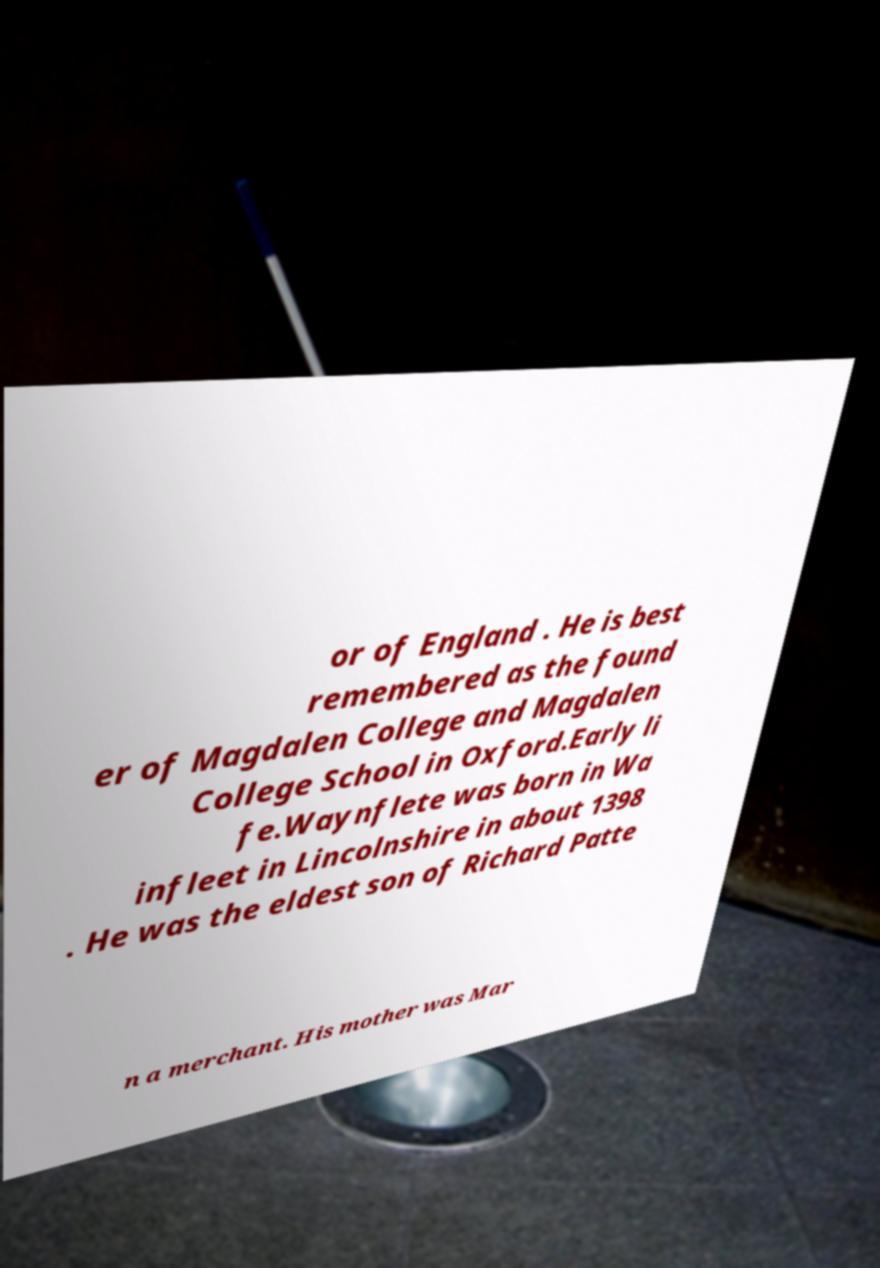Please read and relay the text visible in this image. What does it say? or of England . He is best remembered as the found er of Magdalen College and Magdalen College School in Oxford.Early li fe.Waynflete was born in Wa infleet in Lincolnshire in about 1398 . He was the eldest son of Richard Patte n a merchant. His mother was Mar 